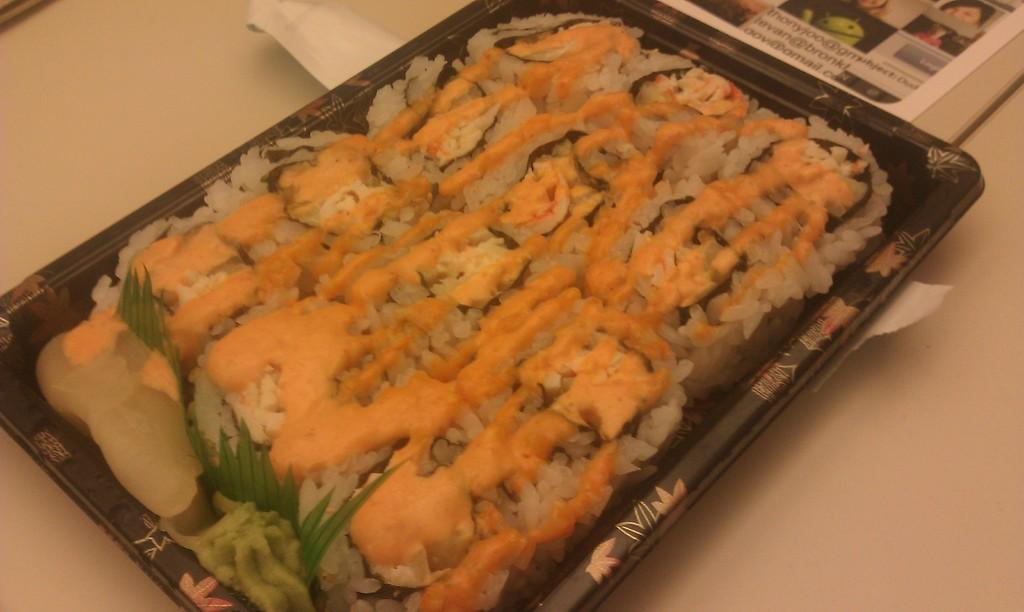What is the color of the tray containing the food item in the image? The tray containing the food item is black. What is placed on top of the food item in the image? There is a paper with images on top of the food item. What type of lace can be seen hanging from the drain in the image? There is no lace or drain present in the image. How many pigs are visible in the image? There are no pigs present in the image. 